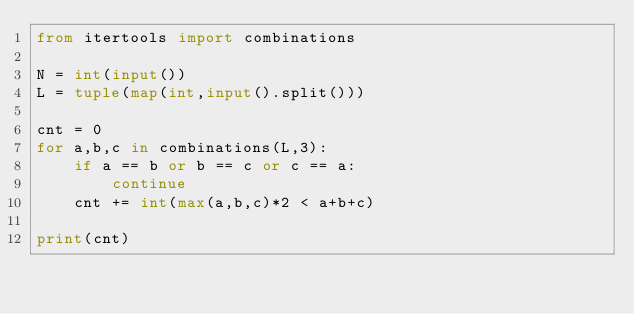<code> <loc_0><loc_0><loc_500><loc_500><_Python_>from itertools import combinations

N = int(input())
L = tuple(map(int,input().split()))

cnt = 0
for a,b,c in combinations(L,3):
    if a == b or b == c or c == a:
        continue
    cnt += int(max(a,b,c)*2 < a+b+c)

print(cnt)</code> 